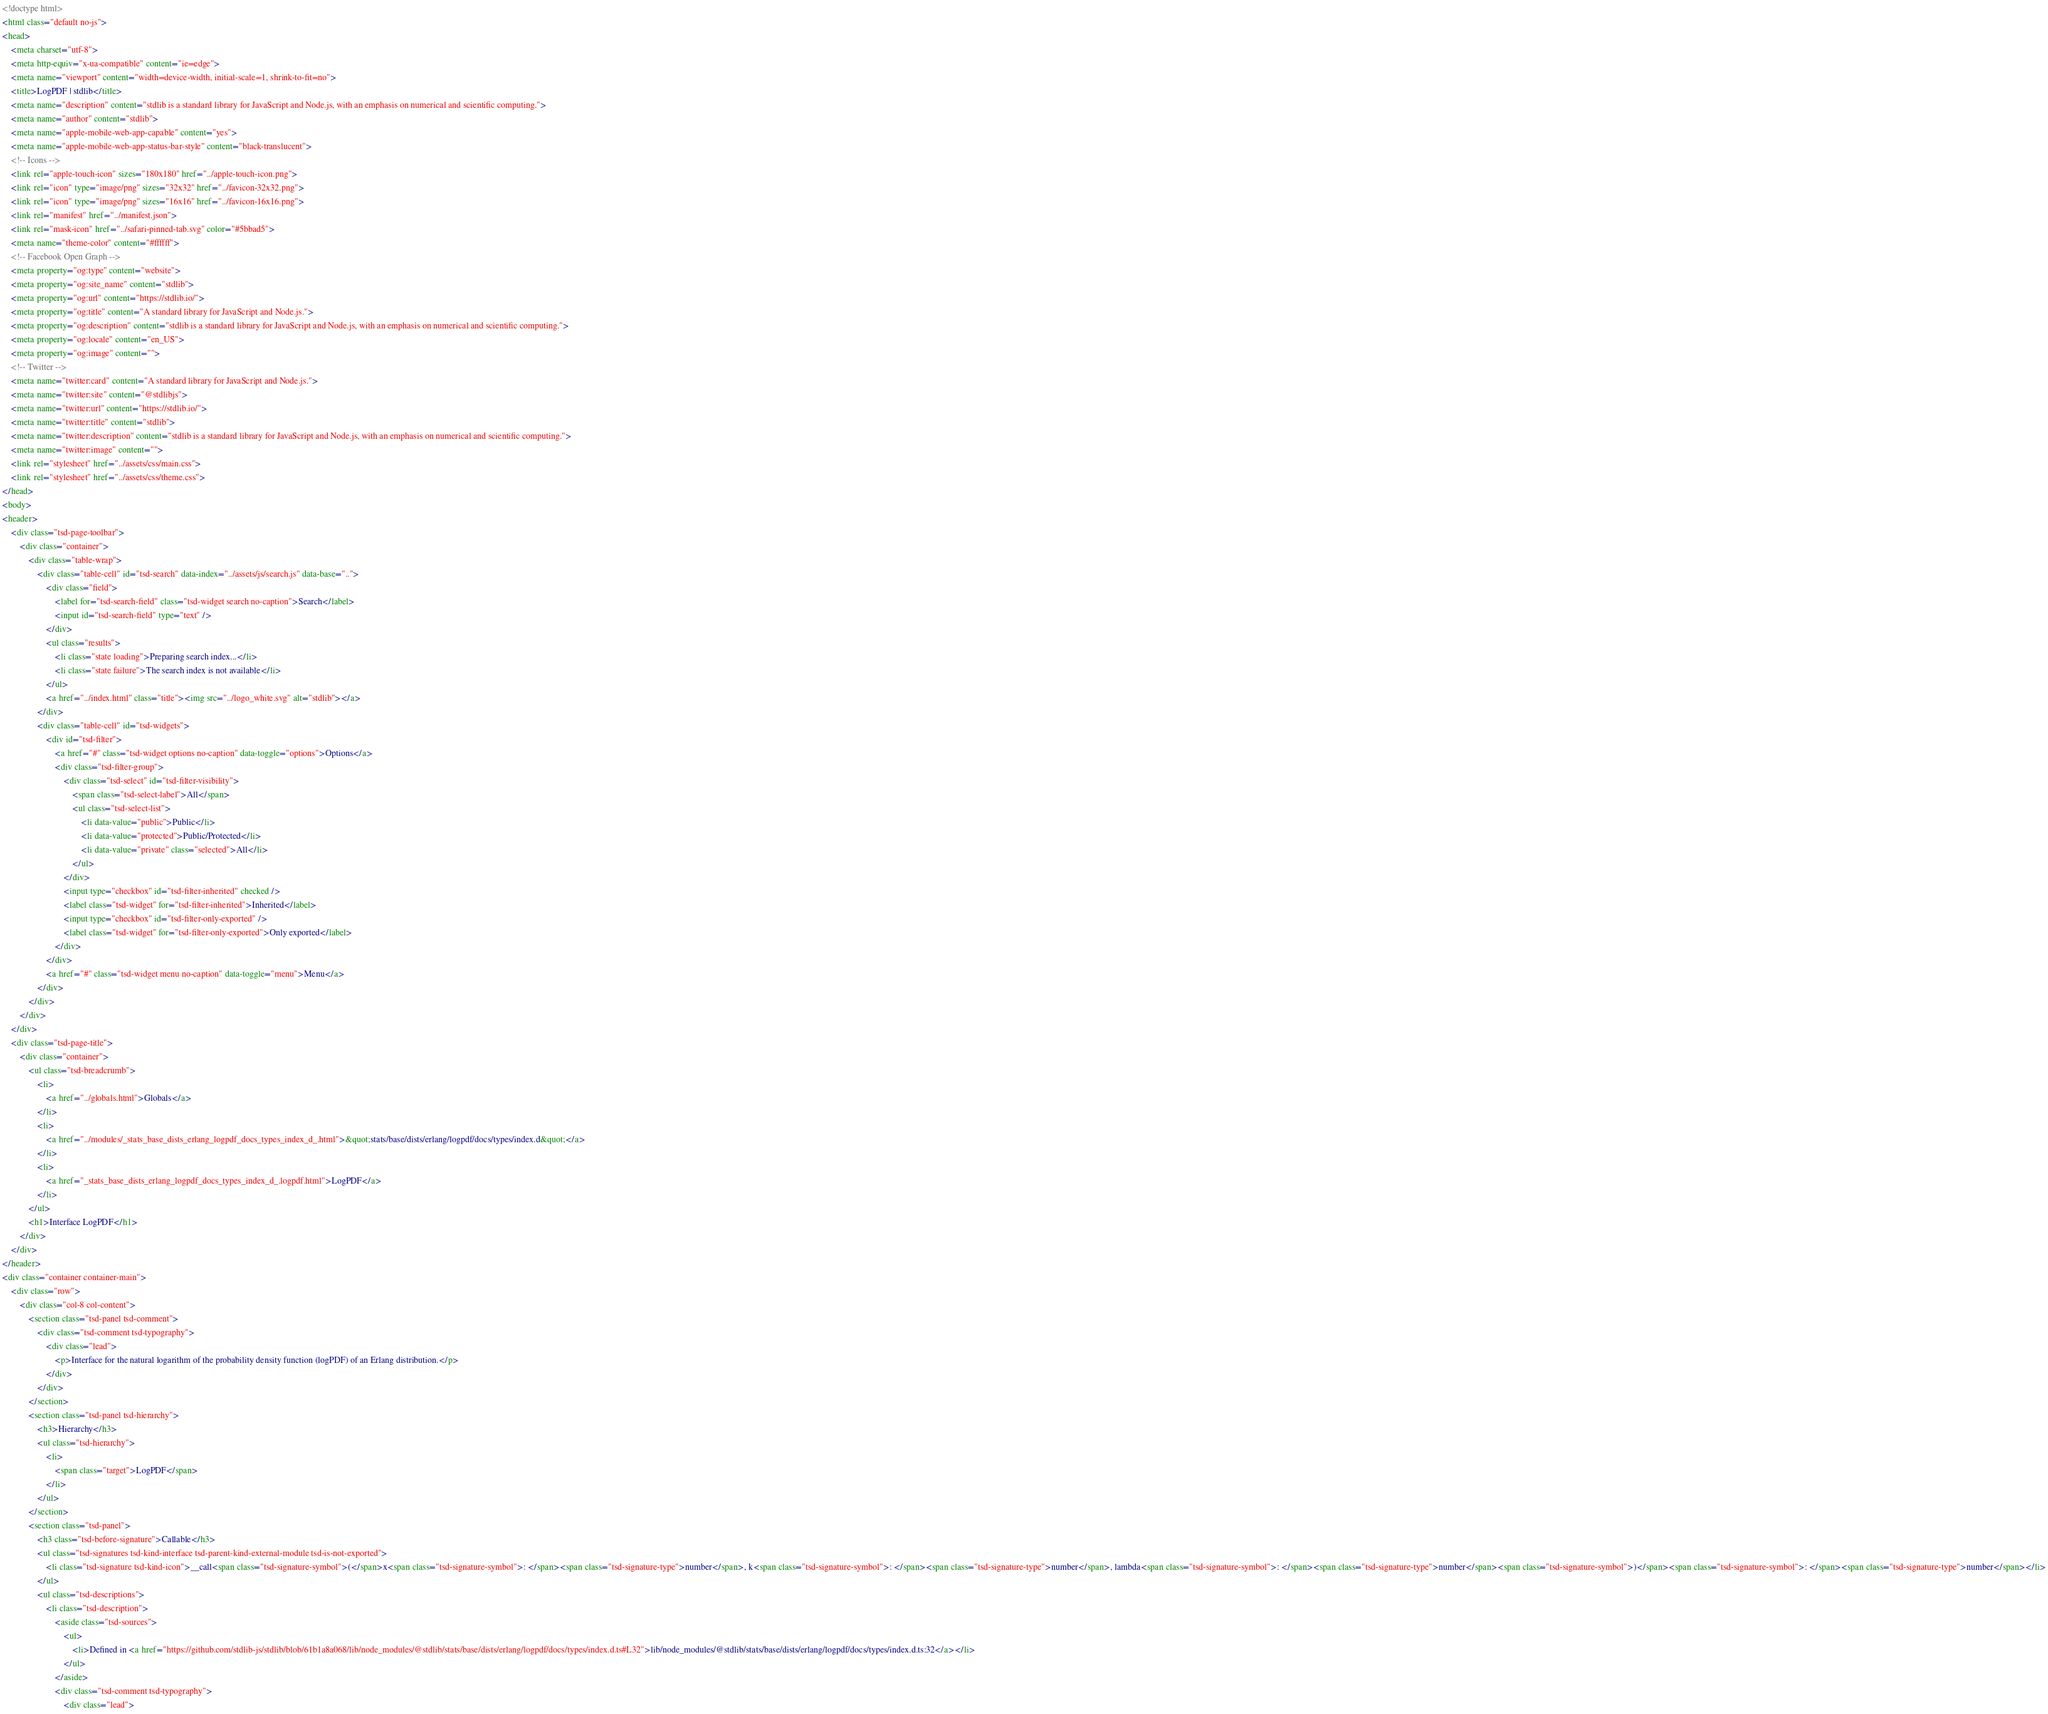Convert code to text. <code><loc_0><loc_0><loc_500><loc_500><_HTML_><!doctype html>
<html class="default no-js">
<head>
	<meta charset="utf-8">
	<meta http-equiv="x-ua-compatible" content="ie=edge">
	<meta name="viewport" content="width=device-width, initial-scale=1, shrink-to-fit=no">
	<title>LogPDF | stdlib</title>
	<meta name="description" content="stdlib is a standard library for JavaScript and Node.js, with an emphasis on numerical and scientific computing.">
	<meta name="author" content="stdlib">
	<meta name="apple-mobile-web-app-capable" content="yes">
	<meta name="apple-mobile-web-app-status-bar-style" content="black-translucent">
	<!-- Icons -->
	<link rel="apple-touch-icon" sizes="180x180" href="../apple-touch-icon.png">
	<link rel="icon" type="image/png" sizes="32x32" href="../favicon-32x32.png">
	<link rel="icon" type="image/png" sizes="16x16" href="../favicon-16x16.png">
	<link rel="manifest" href="../manifest.json">
	<link rel="mask-icon" href="../safari-pinned-tab.svg" color="#5bbad5">
	<meta name="theme-color" content="#ffffff">
	<!-- Facebook Open Graph -->
	<meta property="og:type" content="website">
	<meta property="og:site_name" content="stdlib">
	<meta property="og:url" content="https://stdlib.io/">
	<meta property="og:title" content="A standard library for JavaScript and Node.js.">
	<meta property="og:description" content="stdlib is a standard library for JavaScript and Node.js, with an emphasis on numerical and scientific computing.">
	<meta property="og:locale" content="en_US">
	<meta property="og:image" content="">
	<!-- Twitter -->
	<meta name="twitter:card" content="A standard library for JavaScript and Node.js.">
	<meta name="twitter:site" content="@stdlibjs">
	<meta name="twitter:url" content="https://stdlib.io/">
	<meta name="twitter:title" content="stdlib">
	<meta name="twitter:description" content="stdlib is a standard library for JavaScript and Node.js, with an emphasis on numerical and scientific computing.">
	<meta name="twitter:image" content="">
	<link rel="stylesheet" href="../assets/css/main.css">
	<link rel="stylesheet" href="../assets/css/theme.css">
</head>
<body>
<header>
	<div class="tsd-page-toolbar">
		<div class="container">
			<div class="table-wrap">
				<div class="table-cell" id="tsd-search" data-index="../assets/js/search.js" data-base="..">
					<div class="field">
						<label for="tsd-search-field" class="tsd-widget search no-caption">Search</label>
						<input id="tsd-search-field" type="text" />
					</div>
					<ul class="results">
						<li class="state loading">Preparing search index...</li>
						<li class="state failure">The search index is not available</li>
					</ul>
					<a href="../index.html" class="title"><img src="../logo_white.svg" alt="stdlib"></a>
				</div>
				<div class="table-cell" id="tsd-widgets">
					<div id="tsd-filter">
						<a href="#" class="tsd-widget options no-caption" data-toggle="options">Options</a>
						<div class="tsd-filter-group">
							<div class="tsd-select" id="tsd-filter-visibility">
								<span class="tsd-select-label">All</span>
								<ul class="tsd-select-list">
									<li data-value="public">Public</li>
									<li data-value="protected">Public/Protected</li>
									<li data-value="private" class="selected">All</li>
								</ul>
							</div>
							<input type="checkbox" id="tsd-filter-inherited" checked />
							<label class="tsd-widget" for="tsd-filter-inherited">Inherited</label>
							<input type="checkbox" id="tsd-filter-only-exported" />
							<label class="tsd-widget" for="tsd-filter-only-exported">Only exported</label>
						</div>
					</div>
					<a href="#" class="tsd-widget menu no-caption" data-toggle="menu">Menu</a>
				</div>
			</div>
		</div>
	</div>
	<div class="tsd-page-title">
		<div class="container">
			<ul class="tsd-breadcrumb">
				<li>
					<a href="../globals.html">Globals</a>
				</li>
				<li>
					<a href="../modules/_stats_base_dists_erlang_logpdf_docs_types_index_d_.html">&quot;stats/base/dists/erlang/logpdf/docs/types/index.d&quot;</a>
				</li>
				<li>
					<a href="_stats_base_dists_erlang_logpdf_docs_types_index_d_.logpdf.html">LogPDF</a>
				</li>
			</ul>
			<h1>Interface LogPDF</h1>
		</div>
	</div>
</header>
<div class="container container-main">
	<div class="row">
		<div class="col-8 col-content">
			<section class="tsd-panel tsd-comment">
				<div class="tsd-comment tsd-typography">
					<div class="lead">
						<p>Interface for the natural logarithm of the probability density function (logPDF) of an Erlang distribution.</p>
					</div>
				</div>
			</section>
			<section class="tsd-panel tsd-hierarchy">
				<h3>Hierarchy</h3>
				<ul class="tsd-hierarchy">
					<li>
						<span class="target">LogPDF</span>
					</li>
				</ul>
			</section>
			<section class="tsd-panel">
				<h3 class="tsd-before-signature">Callable</h3>
				<ul class="tsd-signatures tsd-kind-interface tsd-parent-kind-external-module tsd-is-not-exported">
					<li class="tsd-signature tsd-kind-icon">__call<span class="tsd-signature-symbol">(</span>x<span class="tsd-signature-symbol">: </span><span class="tsd-signature-type">number</span>, k<span class="tsd-signature-symbol">: </span><span class="tsd-signature-type">number</span>, lambda<span class="tsd-signature-symbol">: </span><span class="tsd-signature-type">number</span><span class="tsd-signature-symbol">)</span><span class="tsd-signature-symbol">: </span><span class="tsd-signature-type">number</span></li>
				</ul>
				<ul class="tsd-descriptions">
					<li class="tsd-description">
						<aside class="tsd-sources">
							<ul>
								<li>Defined in <a href="https://github.com/stdlib-js/stdlib/blob/61b1a8a068/lib/node_modules/@stdlib/stats/base/dists/erlang/logpdf/docs/types/index.d.ts#L32">lib/node_modules/@stdlib/stats/base/dists/erlang/logpdf/docs/types/index.d.ts:32</a></li>
							</ul>
						</aside>
						<div class="tsd-comment tsd-typography">
							<div class="lead"></code> 